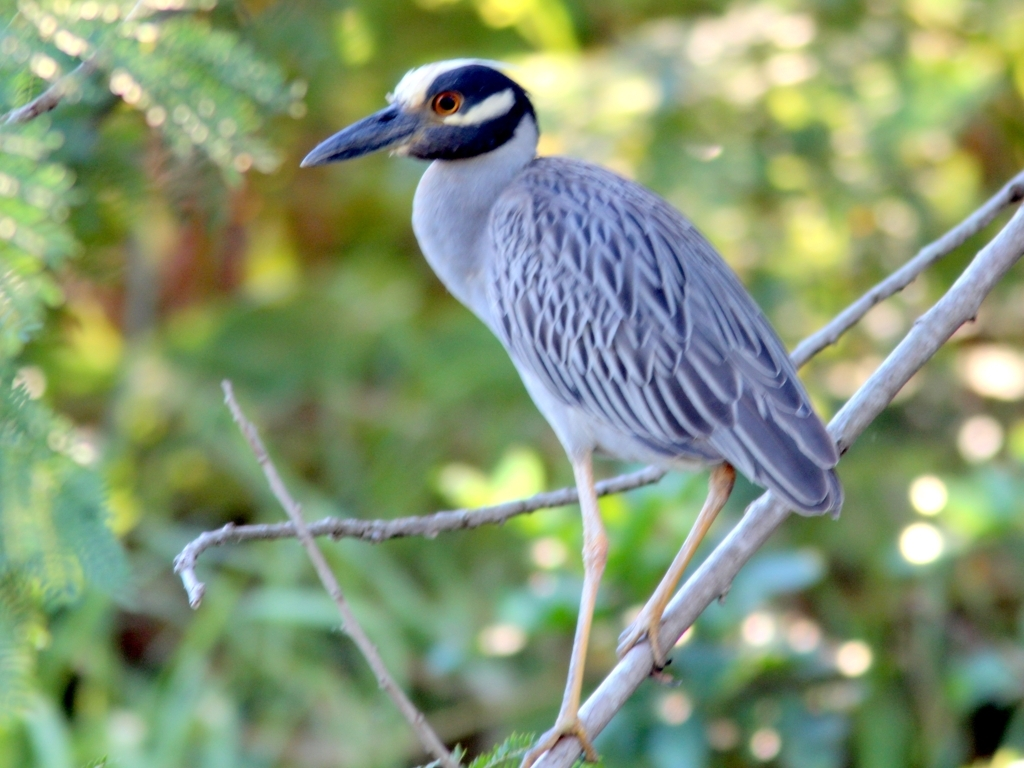What is the exposure level in the image?
A. Underexposed
B. Moderate
C. Perfect
D. Overexposed The exposure in the image can be considered 'Moderate' (Option B). The photo is well-lit and clear, with details visible in the bird's feathers. There are no overt signs of the image being too bright or too dark, which suggests a balanced exposure level. 